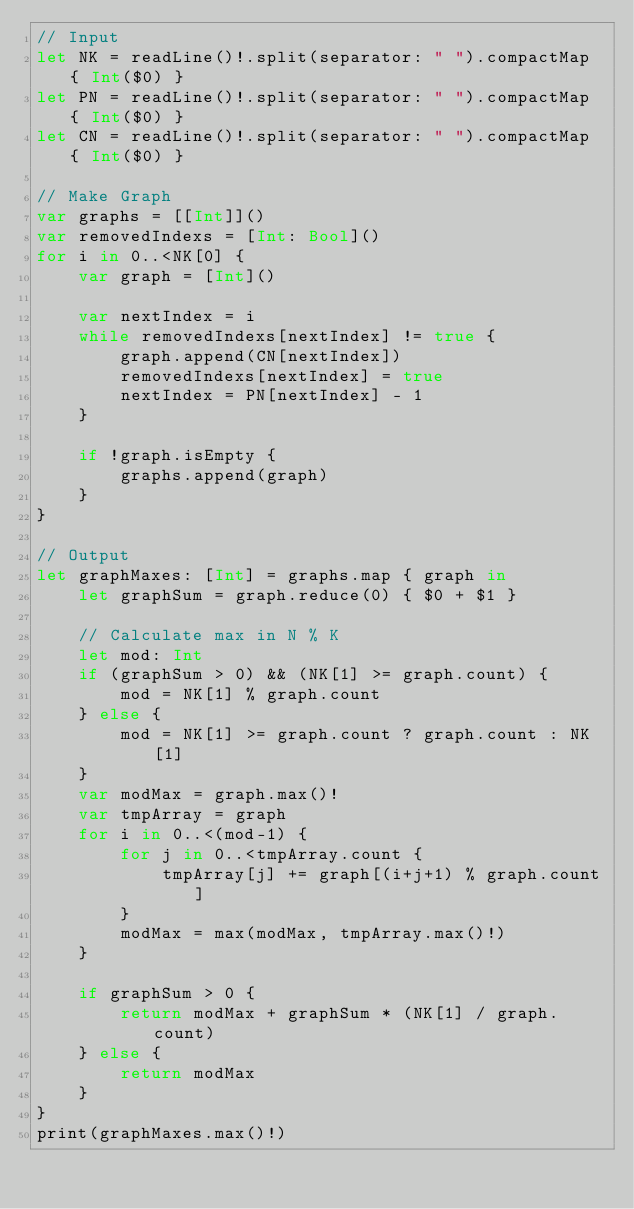<code> <loc_0><loc_0><loc_500><loc_500><_Swift_>// Input
let NK = readLine()!.split(separator: " ").compactMap { Int($0) }
let PN = readLine()!.split(separator: " ").compactMap { Int($0) }
let CN = readLine()!.split(separator: " ").compactMap { Int($0) }

// Make Graph
var graphs = [[Int]]()
var removedIndexs = [Int: Bool]()
for i in 0..<NK[0] {
    var graph = [Int]()

    var nextIndex = i
    while removedIndexs[nextIndex] != true {
        graph.append(CN[nextIndex])
        removedIndexs[nextIndex] = true
        nextIndex = PN[nextIndex] - 1
    }

    if !graph.isEmpty {
        graphs.append(graph)
    }
}

// Output
let graphMaxes: [Int] = graphs.map { graph in
    let graphSum = graph.reduce(0) { $0 + $1 }

    // Calculate max in N % K
    let mod: Int
    if (graphSum > 0) && (NK[1] >= graph.count) {
        mod = NK[1] % graph.count
    } else {
        mod = NK[1] >= graph.count ? graph.count : NK[1]
    }
    var modMax = graph.max()!
    var tmpArray = graph
    for i in 0..<(mod-1) {
        for j in 0..<tmpArray.count {
            tmpArray[j] += graph[(i+j+1) % graph.count]
        }
        modMax = max(modMax, tmpArray.max()!)
    }

    if graphSum > 0 {
        return modMax + graphSum * (NK[1] / graph.count)
    } else {
        return modMax
    }
}
print(graphMaxes.max()!)
</code> 